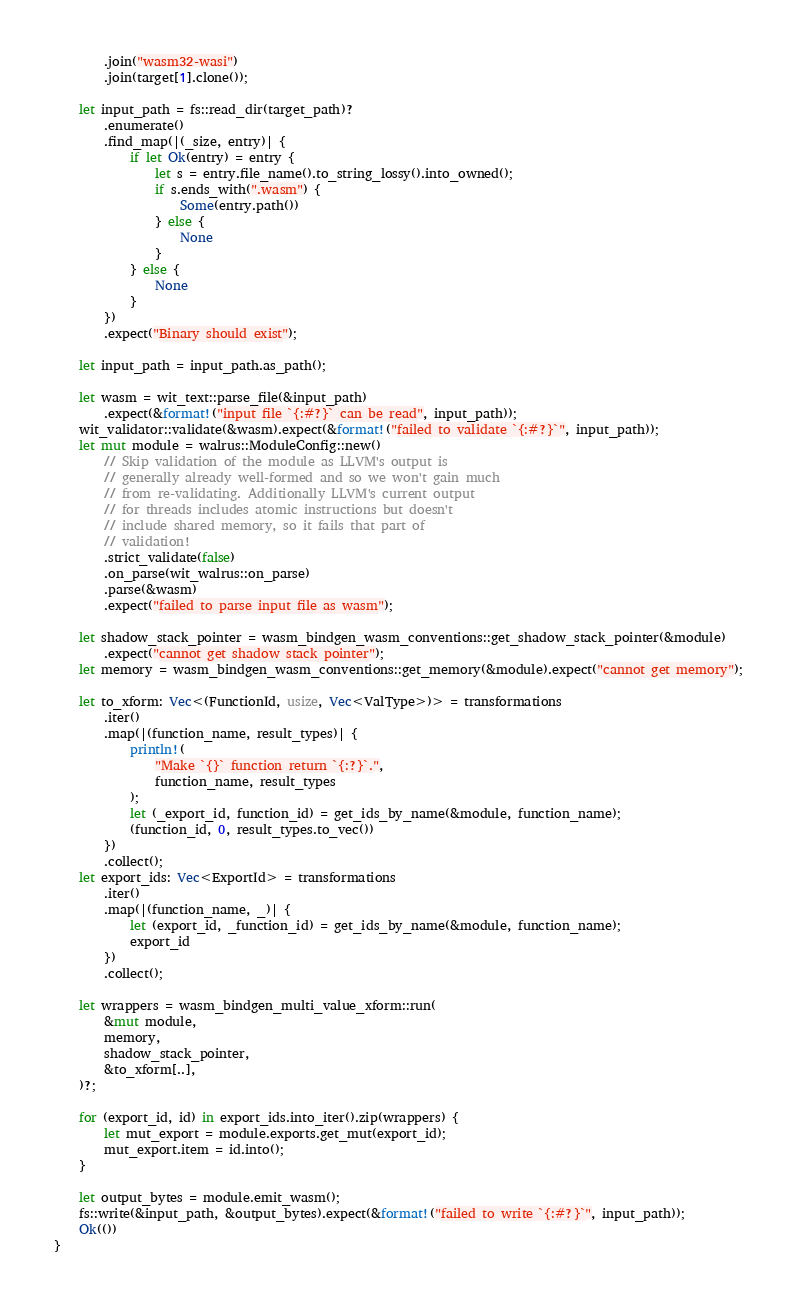Convert code to text. <code><loc_0><loc_0><loc_500><loc_500><_Rust_>        .join("wasm32-wasi")
        .join(target[1].clone());

    let input_path = fs::read_dir(target_path)?
        .enumerate()
        .find_map(|(_size, entry)| {
            if let Ok(entry) = entry {
                let s = entry.file_name().to_string_lossy().into_owned();
                if s.ends_with(".wasm") {
                    Some(entry.path())
                } else {
                    None
                }
            } else {
                None
            }
        })
        .expect("Binary should exist");

    let input_path = input_path.as_path();

    let wasm = wit_text::parse_file(&input_path)
        .expect(&format!("input file `{:#?}` can be read", input_path));
    wit_validator::validate(&wasm).expect(&format!("failed to validate `{:#?}`", input_path));
    let mut module = walrus::ModuleConfig::new()
        // Skip validation of the module as LLVM's output is
        // generally already well-formed and so we won't gain much
        // from re-validating. Additionally LLVM's current output
        // for threads includes atomic instructions but doesn't
        // include shared memory, so it fails that part of
        // validation!
        .strict_validate(false)
        .on_parse(wit_walrus::on_parse)
        .parse(&wasm)
        .expect("failed to parse input file as wasm");

    let shadow_stack_pointer = wasm_bindgen_wasm_conventions::get_shadow_stack_pointer(&module)
        .expect("cannot get shadow stack pointer");
    let memory = wasm_bindgen_wasm_conventions::get_memory(&module).expect("cannot get memory");

    let to_xform: Vec<(FunctionId, usize, Vec<ValType>)> = transformations
        .iter()
        .map(|(function_name, result_types)| {
            println!(
                "Make `{}` function return `{:?}`.",
                function_name, result_types
            );
            let (_export_id, function_id) = get_ids_by_name(&module, function_name);
            (function_id, 0, result_types.to_vec())
        })
        .collect();
    let export_ids: Vec<ExportId> = transformations
        .iter()
        .map(|(function_name, _)| {
            let (export_id, _function_id) = get_ids_by_name(&module, function_name);
            export_id
        })
        .collect();

    let wrappers = wasm_bindgen_multi_value_xform::run(
        &mut module,
        memory,
        shadow_stack_pointer,
        &to_xform[..],
    )?;

    for (export_id, id) in export_ids.into_iter().zip(wrappers) {
        let mut_export = module.exports.get_mut(export_id);
        mut_export.item = id.into();
    }

    let output_bytes = module.emit_wasm();
    fs::write(&input_path, &output_bytes).expect(&format!("failed to write `{:#?}`", input_path));
    Ok(())
}
</code> 